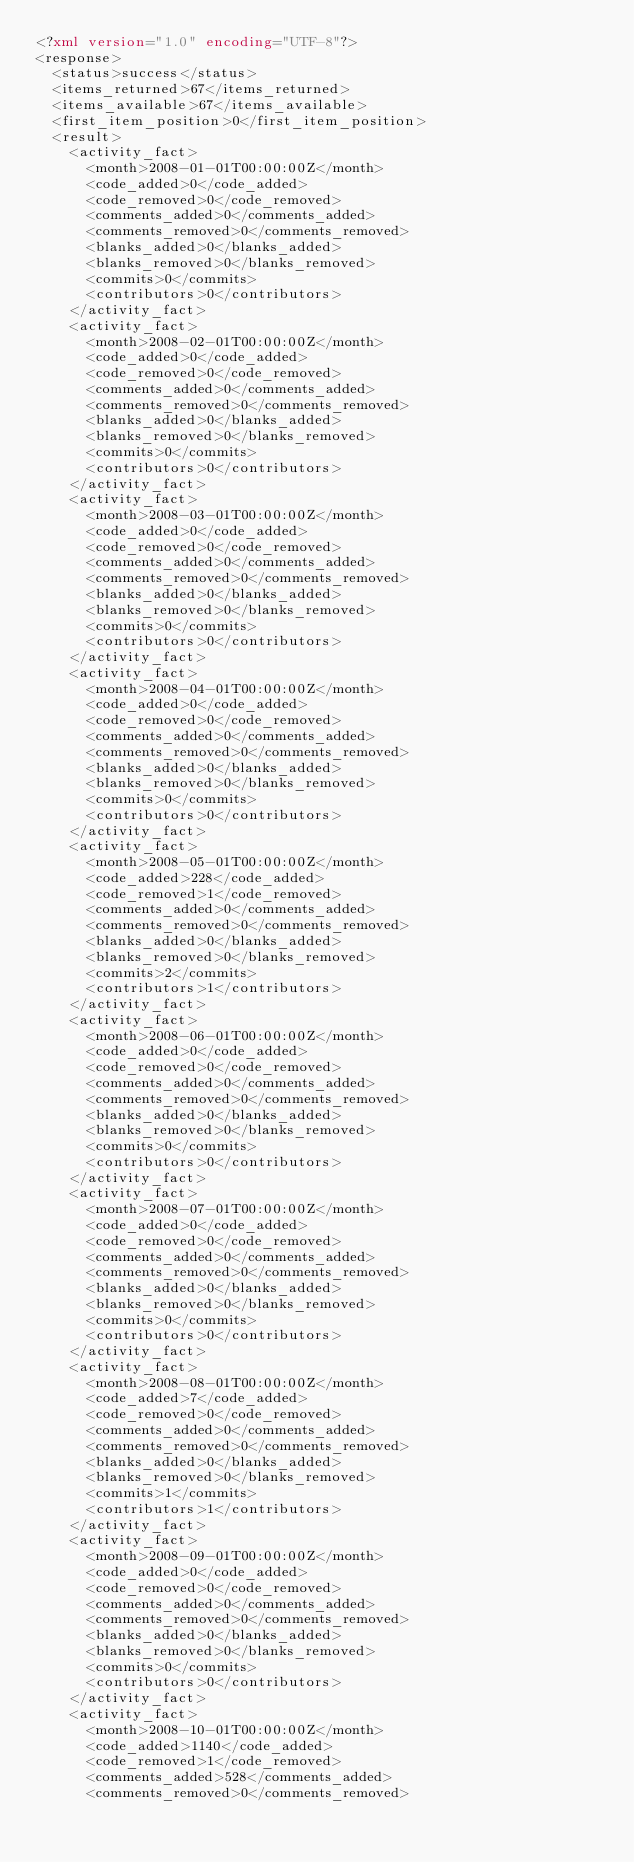Convert code to text. <code><loc_0><loc_0><loc_500><loc_500><_XML_><?xml version="1.0" encoding="UTF-8"?>
<response>
  <status>success</status>
  <items_returned>67</items_returned>
  <items_available>67</items_available>
  <first_item_position>0</first_item_position>
  <result>
    <activity_fact>
      <month>2008-01-01T00:00:00Z</month>
      <code_added>0</code_added>
      <code_removed>0</code_removed>
      <comments_added>0</comments_added>
      <comments_removed>0</comments_removed>
      <blanks_added>0</blanks_added>
      <blanks_removed>0</blanks_removed>
      <commits>0</commits>
      <contributors>0</contributors>
    </activity_fact>
    <activity_fact>
      <month>2008-02-01T00:00:00Z</month>
      <code_added>0</code_added>
      <code_removed>0</code_removed>
      <comments_added>0</comments_added>
      <comments_removed>0</comments_removed>
      <blanks_added>0</blanks_added>
      <blanks_removed>0</blanks_removed>
      <commits>0</commits>
      <contributors>0</contributors>
    </activity_fact>
    <activity_fact>
      <month>2008-03-01T00:00:00Z</month>
      <code_added>0</code_added>
      <code_removed>0</code_removed>
      <comments_added>0</comments_added>
      <comments_removed>0</comments_removed>
      <blanks_added>0</blanks_added>
      <blanks_removed>0</blanks_removed>
      <commits>0</commits>
      <contributors>0</contributors>
    </activity_fact>
    <activity_fact>
      <month>2008-04-01T00:00:00Z</month>
      <code_added>0</code_added>
      <code_removed>0</code_removed>
      <comments_added>0</comments_added>
      <comments_removed>0</comments_removed>
      <blanks_added>0</blanks_added>
      <blanks_removed>0</blanks_removed>
      <commits>0</commits>
      <contributors>0</contributors>
    </activity_fact>
    <activity_fact>
      <month>2008-05-01T00:00:00Z</month>
      <code_added>228</code_added>
      <code_removed>1</code_removed>
      <comments_added>0</comments_added>
      <comments_removed>0</comments_removed>
      <blanks_added>0</blanks_added>
      <blanks_removed>0</blanks_removed>
      <commits>2</commits>
      <contributors>1</contributors>
    </activity_fact>
    <activity_fact>
      <month>2008-06-01T00:00:00Z</month>
      <code_added>0</code_added>
      <code_removed>0</code_removed>
      <comments_added>0</comments_added>
      <comments_removed>0</comments_removed>
      <blanks_added>0</blanks_added>
      <blanks_removed>0</blanks_removed>
      <commits>0</commits>
      <contributors>0</contributors>
    </activity_fact>
    <activity_fact>
      <month>2008-07-01T00:00:00Z</month>
      <code_added>0</code_added>
      <code_removed>0</code_removed>
      <comments_added>0</comments_added>
      <comments_removed>0</comments_removed>
      <blanks_added>0</blanks_added>
      <blanks_removed>0</blanks_removed>
      <commits>0</commits>
      <contributors>0</contributors>
    </activity_fact>
    <activity_fact>
      <month>2008-08-01T00:00:00Z</month>
      <code_added>7</code_added>
      <code_removed>0</code_removed>
      <comments_added>0</comments_added>
      <comments_removed>0</comments_removed>
      <blanks_added>0</blanks_added>
      <blanks_removed>0</blanks_removed>
      <commits>1</commits>
      <contributors>1</contributors>
    </activity_fact>
    <activity_fact>
      <month>2008-09-01T00:00:00Z</month>
      <code_added>0</code_added>
      <code_removed>0</code_removed>
      <comments_added>0</comments_added>
      <comments_removed>0</comments_removed>
      <blanks_added>0</blanks_added>
      <blanks_removed>0</blanks_removed>
      <commits>0</commits>
      <contributors>0</contributors>
    </activity_fact>
    <activity_fact>
      <month>2008-10-01T00:00:00Z</month>
      <code_added>1140</code_added>
      <code_removed>1</code_removed>
      <comments_added>528</comments_added>
      <comments_removed>0</comments_removed></code> 